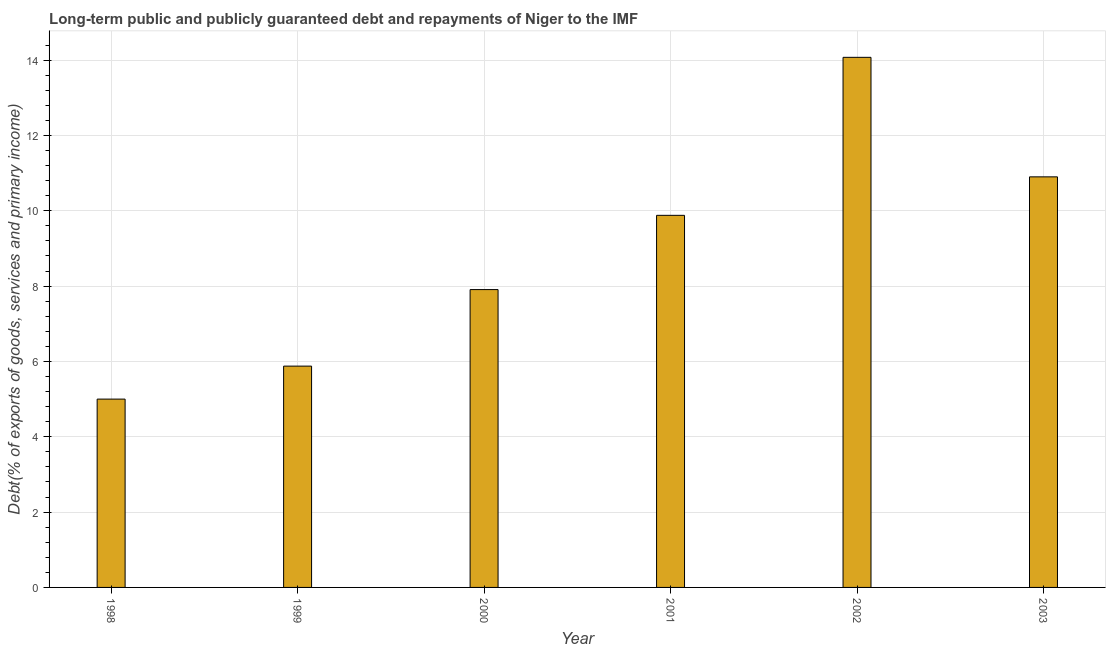Does the graph contain any zero values?
Make the answer very short. No. Does the graph contain grids?
Make the answer very short. Yes. What is the title of the graph?
Give a very brief answer. Long-term public and publicly guaranteed debt and repayments of Niger to the IMF. What is the label or title of the X-axis?
Ensure brevity in your answer.  Year. What is the label or title of the Y-axis?
Ensure brevity in your answer.  Debt(% of exports of goods, services and primary income). What is the debt service in 1999?
Provide a short and direct response. 5.88. Across all years, what is the maximum debt service?
Provide a short and direct response. 14.07. Across all years, what is the minimum debt service?
Your answer should be very brief. 5. In which year was the debt service maximum?
Offer a very short reply. 2002. What is the sum of the debt service?
Provide a succinct answer. 53.64. What is the difference between the debt service in 1998 and 1999?
Your response must be concise. -0.88. What is the average debt service per year?
Provide a succinct answer. 8.94. What is the median debt service?
Provide a short and direct response. 8.89. In how many years, is the debt service greater than 5.6 %?
Provide a succinct answer. 5. What is the ratio of the debt service in 1998 to that in 2000?
Offer a terse response. 0.63. Is the debt service in 2000 less than that in 2001?
Provide a succinct answer. Yes. Is the difference between the debt service in 2001 and 2003 greater than the difference between any two years?
Offer a very short reply. No. What is the difference between the highest and the second highest debt service?
Offer a terse response. 3.17. What is the difference between the highest and the lowest debt service?
Provide a succinct answer. 9.07. How many bars are there?
Offer a very short reply. 6. Are all the bars in the graph horizontal?
Give a very brief answer. No. How many years are there in the graph?
Provide a succinct answer. 6. What is the Debt(% of exports of goods, services and primary income) of 1999?
Make the answer very short. 5.88. What is the Debt(% of exports of goods, services and primary income) of 2000?
Your answer should be compact. 7.91. What is the Debt(% of exports of goods, services and primary income) of 2001?
Your answer should be very brief. 9.88. What is the Debt(% of exports of goods, services and primary income) in 2002?
Give a very brief answer. 14.07. What is the Debt(% of exports of goods, services and primary income) in 2003?
Ensure brevity in your answer.  10.9. What is the difference between the Debt(% of exports of goods, services and primary income) in 1998 and 1999?
Provide a succinct answer. -0.88. What is the difference between the Debt(% of exports of goods, services and primary income) in 1998 and 2000?
Keep it short and to the point. -2.91. What is the difference between the Debt(% of exports of goods, services and primary income) in 1998 and 2001?
Keep it short and to the point. -4.88. What is the difference between the Debt(% of exports of goods, services and primary income) in 1998 and 2002?
Provide a succinct answer. -9.07. What is the difference between the Debt(% of exports of goods, services and primary income) in 1998 and 2003?
Your answer should be very brief. -5.9. What is the difference between the Debt(% of exports of goods, services and primary income) in 1999 and 2000?
Offer a terse response. -2.03. What is the difference between the Debt(% of exports of goods, services and primary income) in 1999 and 2001?
Your answer should be very brief. -4. What is the difference between the Debt(% of exports of goods, services and primary income) in 1999 and 2002?
Offer a terse response. -8.2. What is the difference between the Debt(% of exports of goods, services and primary income) in 1999 and 2003?
Provide a succinct answer. -5.02. What is the difference between the Debt(% of exports of goods, services and primary income) in 2000 and 2001?
Your answer should be compact. -1.97. What is the difference between the Debt(% of exports of goods, services and primary income) in 2000 and 2002?
Keep it short and to the point. -6.17. What is the difference between the Debt(% of exports of goods, services and primary income) in 2000 and 2003?
Keep it short and to the point. -2.99. What is the difference between the Debt(% of exports of goods, services and primary income) in 2001 and 2002?
Ensure brevity in your answer.  -4.2. What is the difference between the Debt(% of exports of goods, services and primary income) in 2001 and 2003?
Your answer should be very brief. -1.02. What is the difference between the Debt(% of exports of goods, services and primary income) in 2002 and 2003?
Ensure brevity in your answer.  3.17. What is the ratio of the Debt(% of exports of goods, services and primary income) in 1998 to that in 1999?
Make the answer very short. 0.85. What is the ratio of the Debt(% of exports of goods, services and primary income) in 1998 to that in 2000?
Provide a short and direct response. 0.63. What is the ratio of the Debt(% of exports of goods, services and primary income) in 1998 to that in 2001?
Your response must be concise. 0.51. What is the ratio of the Debt(% of exports of goods, services and primary income) in 1998 to that in 2002?
Your answer should be compact. 0.35. What is the ratio of the Debt(% of exports of goods, services and primary income) in 1998 to that in 2003?
Make the answer very short. 0.46. What is the ratio of the Debt(% of exports of goods, services and primary income) in 1999 to that in 2000?
Make the answer very short. 0.74. What is the ratio of the Debt(% of exports of goods, services and primary income) in 1999 to that in 2001?
Ensure brevity in your answer.  0.59. What is the ratio of the Debt(% of exports of goods, services and primary income) in 1999 to that in 2002?
Keep it short and to the point. 0.42. What is the ratio of the Debt(% of exports of goods, services and primary income) in 1999 to that in 2003?
Give a very brief answer. 0.54. What is the ratio of the Debt(% of exports of goods, services and primary income) in 2000 to that in 2001?
Your answer should be very brief. 0.8. What is the ratio of the Debt(% of exports of goods, services and primary income) in 2000 to that in 2002?
Provide a short and direct response. 0.56. What is the ratio of the Debt(% of exports of goods, services and primary income) in 2000 to that in 2003?
Provide a short and direct response. 0.72. What is the ratio of the Debt(% of exports of goods, services and primary income) in 2001 to that in 2002?
Give a very brief answer. 0.7. What is the ratio of the Debt(% of exports of goods, services and primary income) in 2001 to that in 2003?
Offer a very short reply. 0.91. What is the ratio of the Debt(% of exports of goods, services and primary income) in 2002 to that in 2003?
Give a very brief answer. 1.29. 